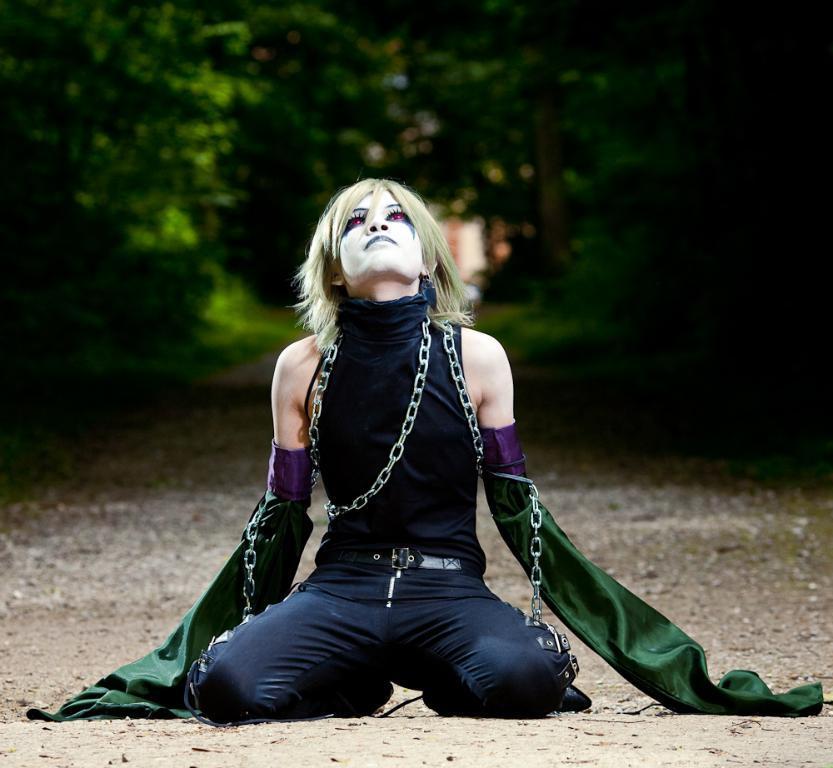Describe this image in one or two sentences. In the center of the image we can see a person in a different costume. And we can see some paint on her face. In the background, we can see it is blurred. 